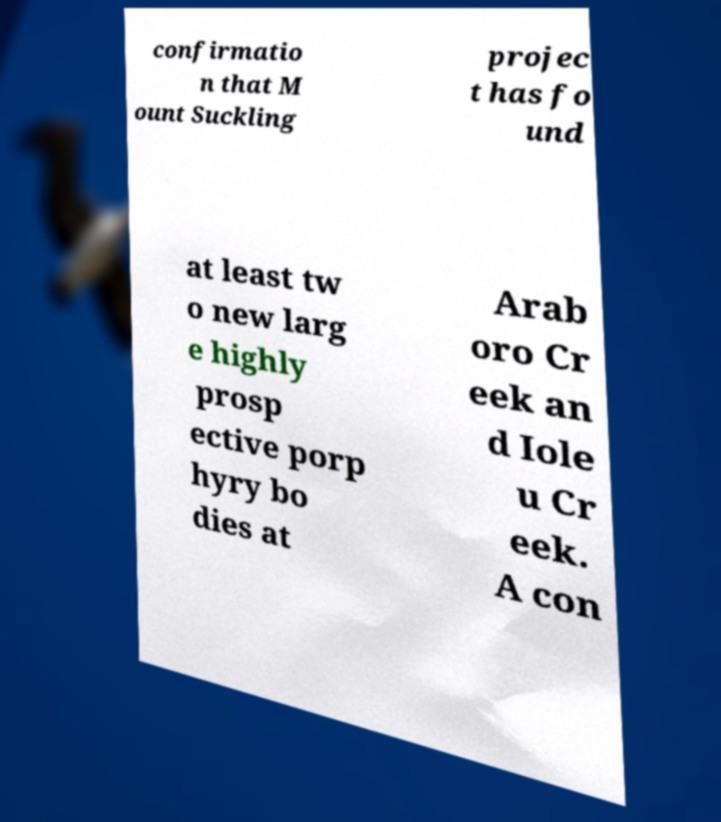Could you assist in decoding the text presented in this image and type it out clearly? confirmatio n that M ount Suckling projec t has fo und at least tw o new larg e highly prosp ective porp hyry bo dies at Arab oro Cr eek an d Iole u Cr eek. A con 